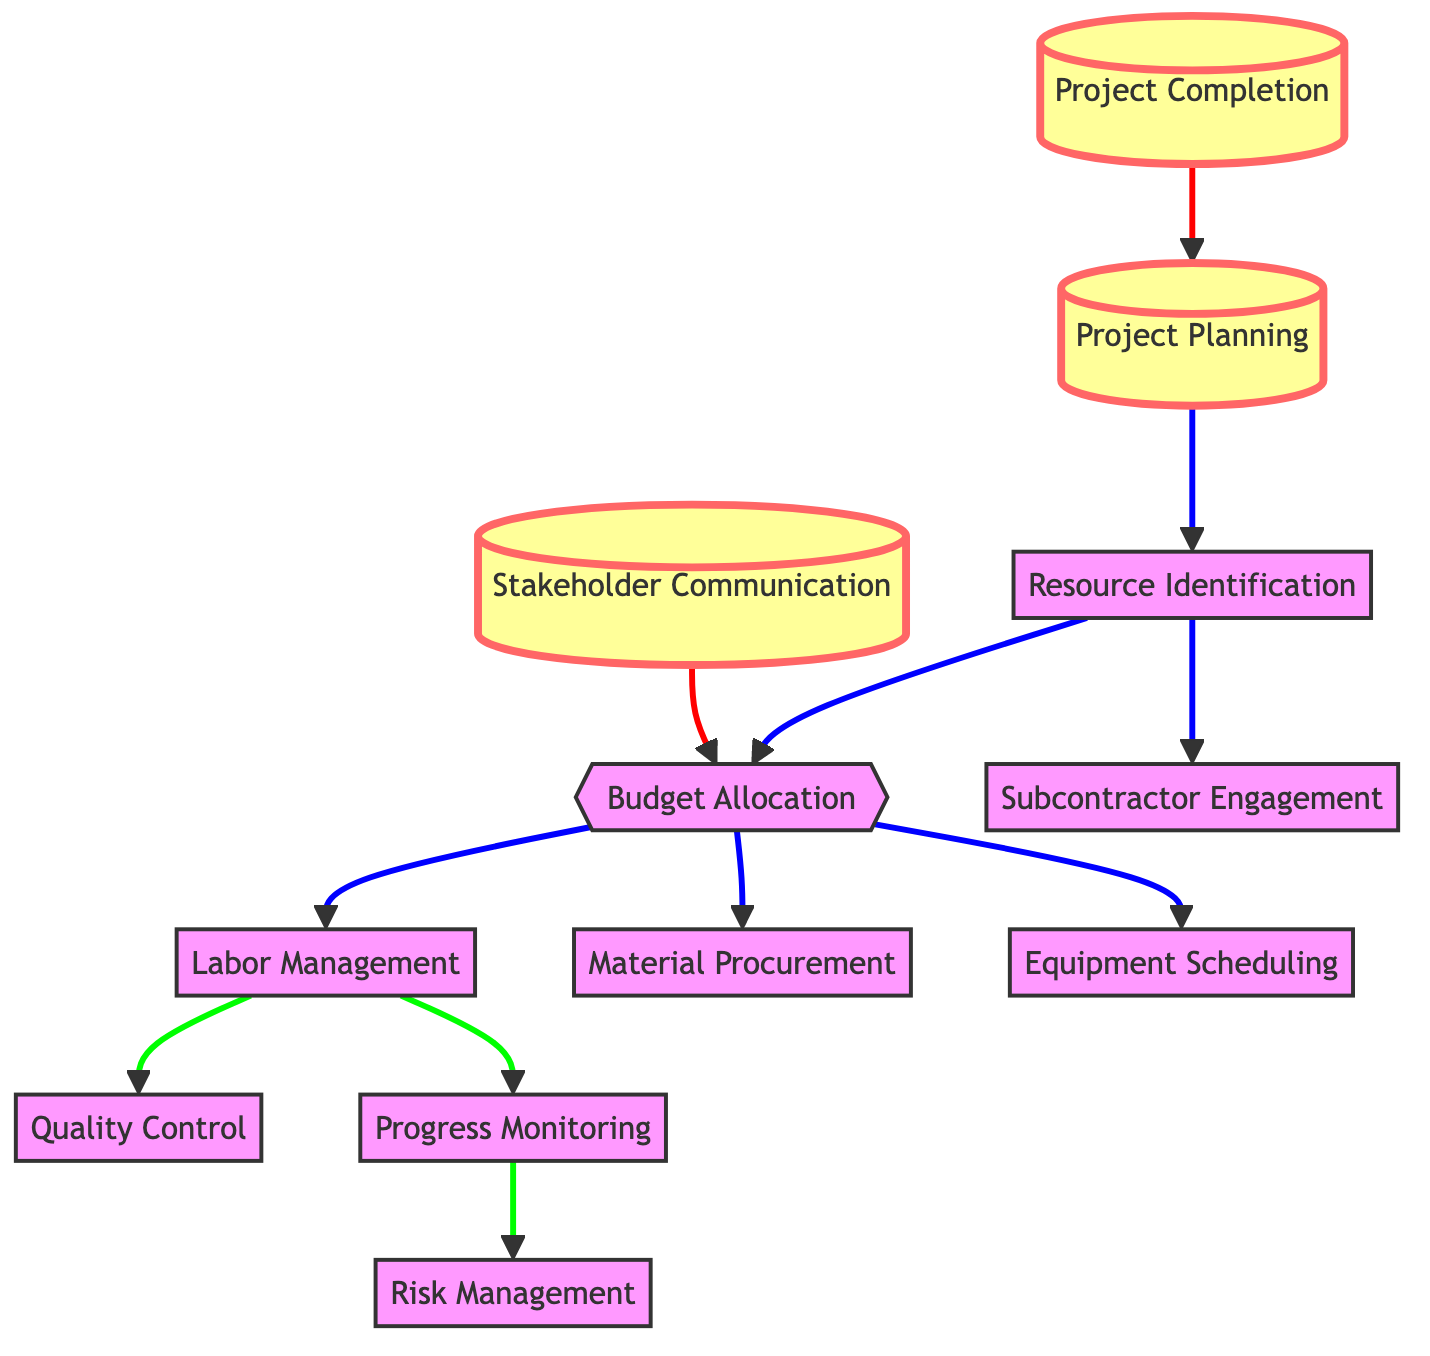What is the starting point of the construction resource allocation pathway? The diagram shows that the starting point is "Project Planning," which connects to "Resource Identification."
Answer: Project Planning How many nodes are represented in the diagram? By counting the distinct stages represented, there are 12 nodes in total, including all steps from project planning to completion.
Answer: 12 What are the three tasks that follow budget allocation? The tasks that follow "Budget Allocation" are "Labor Management," "Material Procurement," and "Equipment Scheduling."
Answer: Labor Management, Material Procurement, Equipment Scheduling Which node directly connects to risk management? "Progress Monitoring" is the only node that connects directly to "Risk Management."
Answer: Progress Monitoring What is the last node in the resource allocation pathway? The last node in the pathway is "Project Completion," which indicates the endpoint of the resource allocation process.
Answer: Project Completion Which task is required before engaging subcontractors? "Resource Identification" must occur before "Subcontractor Engagement," as indicated by the directed edge in the diagram.
Answer: Resource Identification How many relationships are there between project management and budget allocation? There are two direct connections to "Budget Allocation" from "Stakeholder Communication" and "Resource Identification," indicating multiple influences.
Answer: 2 Which tasks are involved after labor management? After "Labor Management," the process moves to "Quality Control" and "Progress Monitoring."
Answer: Quality Control, Progress Monitoring What does the directed edge from project completion indicate? The directed edge from "Project Completion" back to "Project Planning" suggests a cyclical feedback loop for continuous improvement on future projects.
Answer: Cyclical feedback loop 